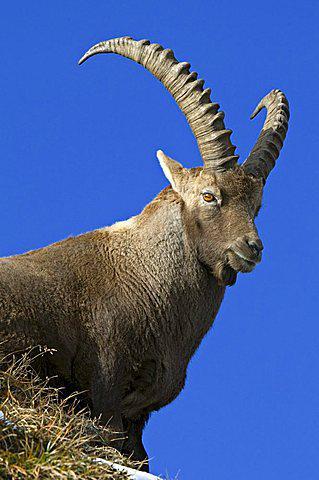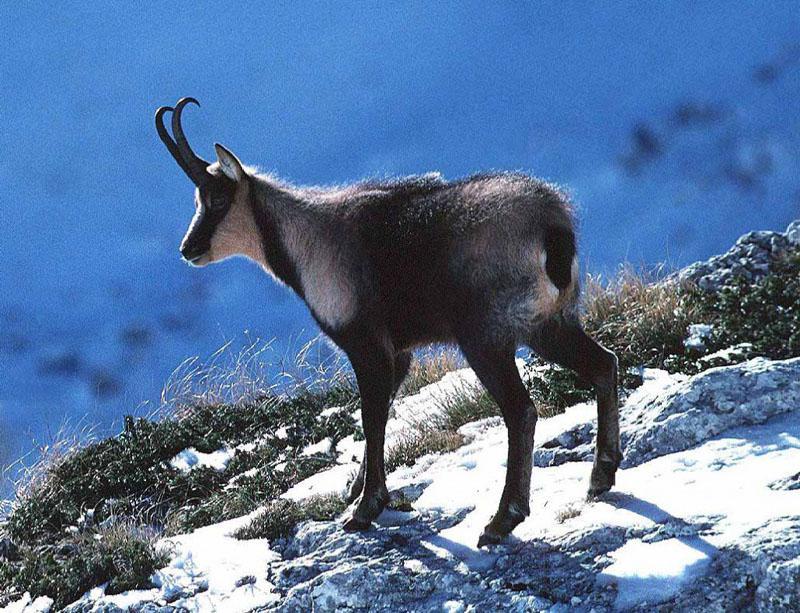The first image is the image on the left, the second image is the image on the right. Given the left and right images, does the statement "There are at least three mountain goats." hold true? Answer yes or no. No. The first image is the image on the left, the second image is the image on the right. Examine the images to the left and right. Is the description "One big horn sheep is facing left." accurate? Answer yes or no. Yes. 